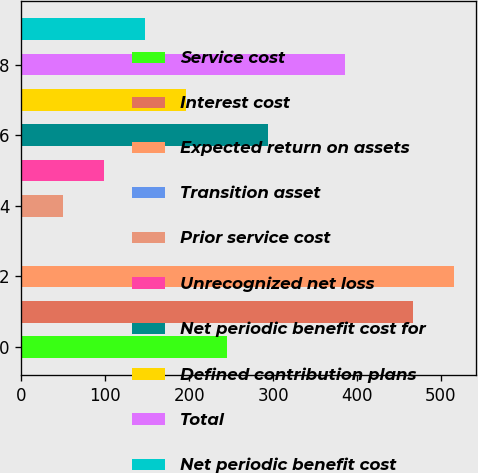Convert chart to OTSL. <chart><loc_0><loc_0><loc_500><loc_500><bar_chart><fcel>Service cost<fcel>Interest cost<fcel>Expected return on assets<fcel>Transition asset<fcel>Prior service cost<fcel>Unrecognized net loss<fcel>Net periodic benefit cost for<fcel>Defined contribution plans<fcel>Total<fcel>Net periodic benefit cost<nl><fcel>245.5<fcel>467<fcel>515.9<fcel>1<fcel>49.9<fcel>98.8<fcel>294.4<fcel>196.6<fcel>386<fcel>147.7<nl></chart> 